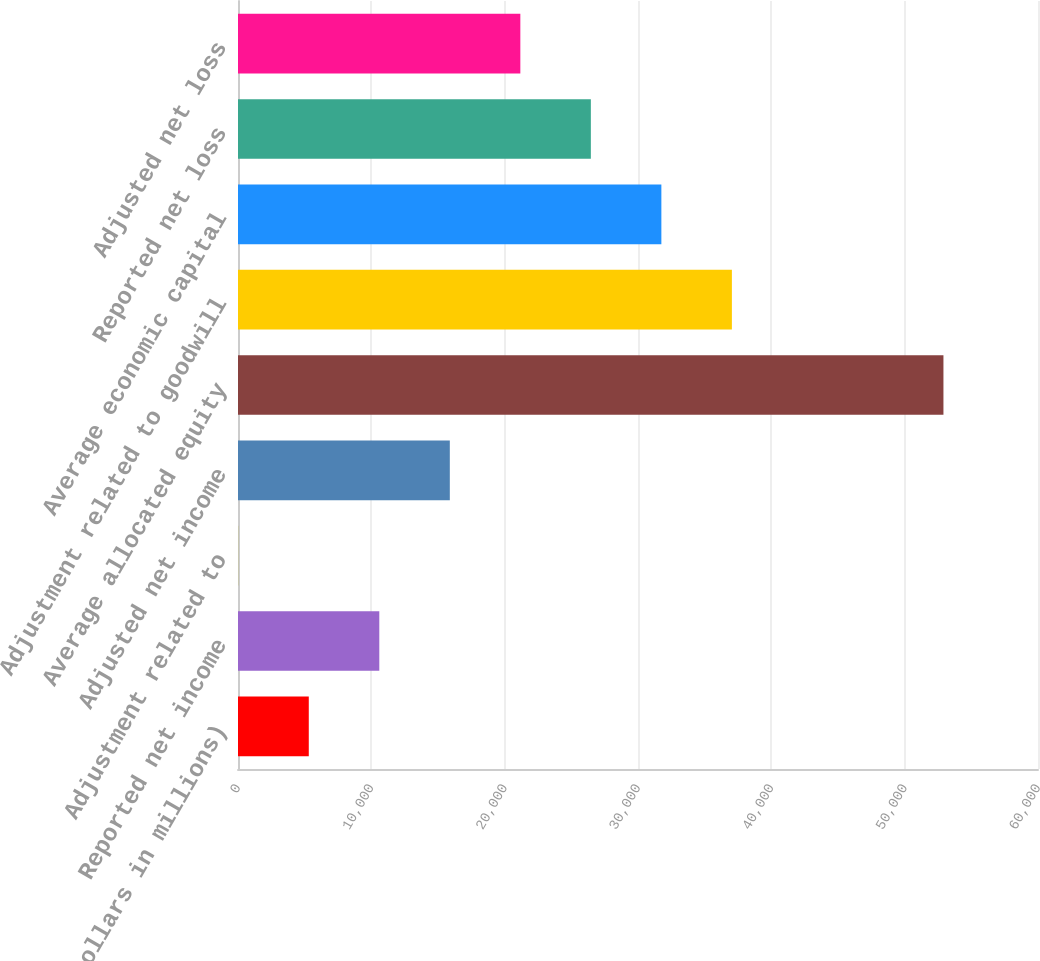Convert chart. <chart><loc_0><loc_0><loc_500><loc_500><bar_chart><fcel>(Dollars in millions)<fcel>Reported net income<fcel>Adjustment related to<fcel>Adjusted net income<fcel>Average allocated equity<fcel>Adjustment related to goodwill<fcel>Average economic capital<fcel>Reported net loss<fcel>Adjusted net loss<nl><fcel>5308.8<fcel>10597.6<fcel>20<fcel>15886.4<fcel>52908<fcel>37041.6<fcel>31752.8<fcel>26464<fcel>21175.2<nl></chart> 